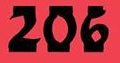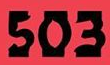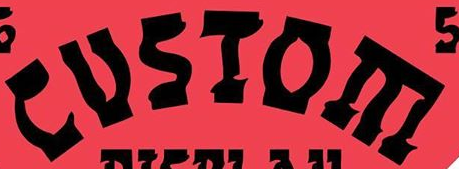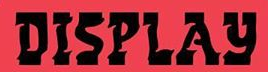Read the text from these images in sequence, separated by a semicolon. 206; 503; CUSIOE; DISPLAY 